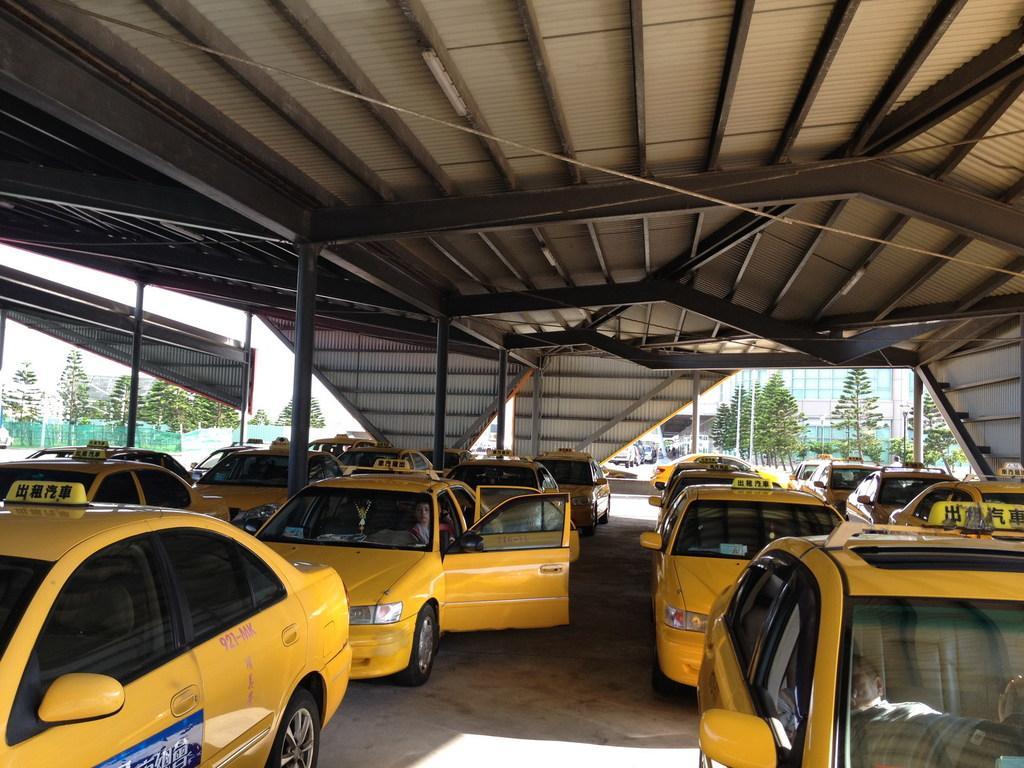Please provide a concise description of this image. In the picture I can see yellow color cars on the ground. In the background I can see poles, buildings, trees, fence, the sky and some other objects. 